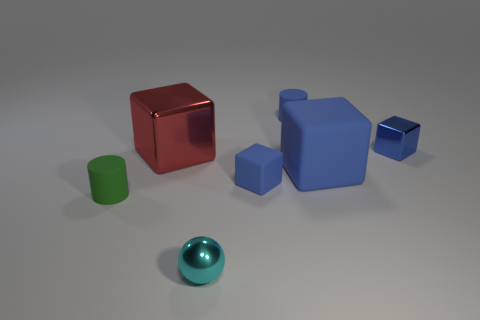Subtract all blue spheres. How many blue cubes are left? 3 Add 3 tiny blue cylinders. How many objects exist? 10 Subtract all brown cubes. Subtract all brown spheres. How many cubes are left? 4 Subtract all blocks. How many objects are left? 3 Subtract 0 purple spheres. How many objects are left? 7 Subtract all tiny blue metallic things. Subtract all small cyan cubes. How many objects are left? 6 Add 7 small matte cubes. How many small matte cubes are left? 8 Add 6 tiny gray matte blocks. How many tiny gray matte blocks exist? 6 